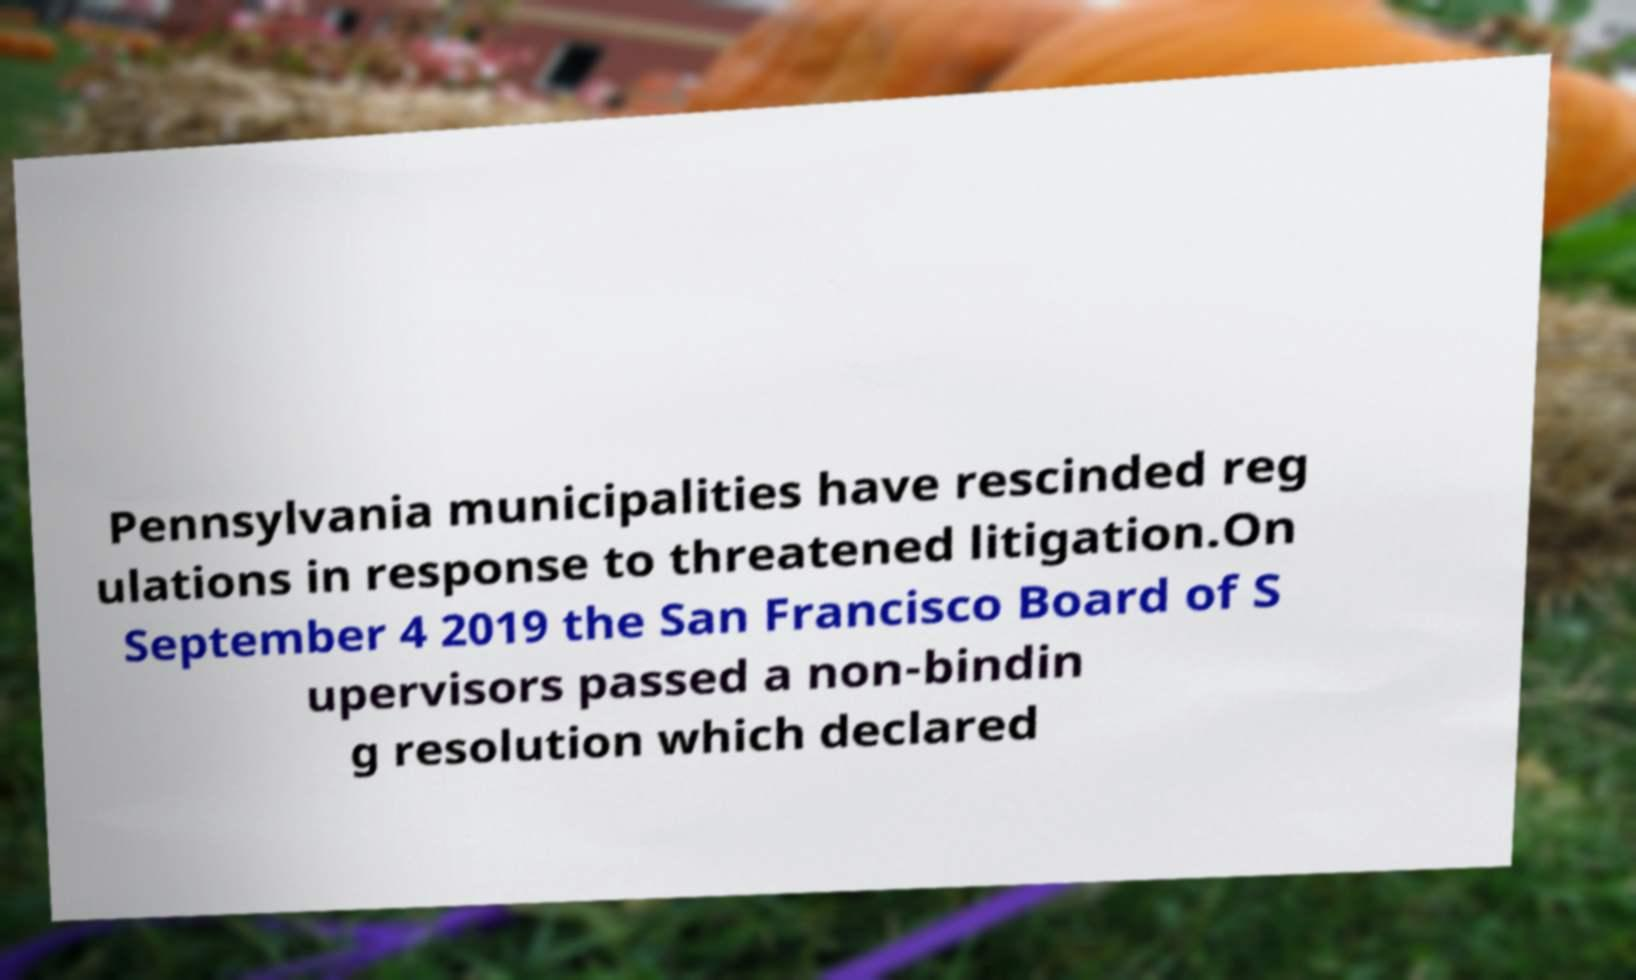I need the written content from this picture converted into text. Can you do that? Pennsylvania municipalities have rescinded reg ulations in response to threatened litigation.On September 4 2019 the San Francisco Board of S upervisors passed a non-bindin g resolution which declared 